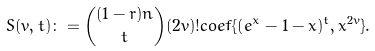<formula> <loc_0><loc_0><loc_500><loc_500>S ( v , t ) \colon = { ( 1 - r ) n \choose t } ( 2 v ) ! c o e f \{ ( e ^ { x } - 1 - x ) ^ { t } , x ^ { 2 v } \} .</formula> 